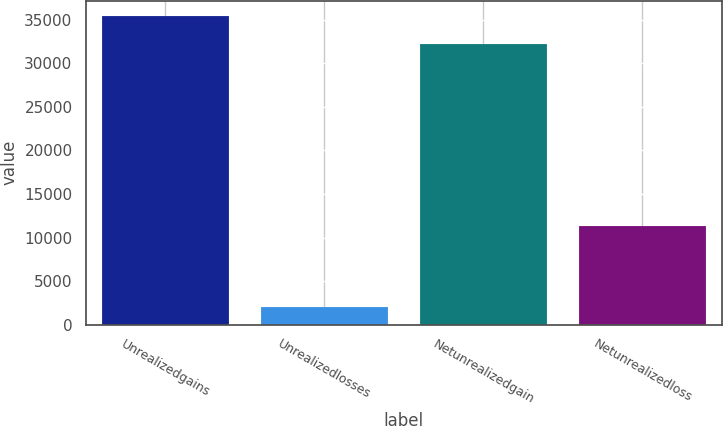<chart> <loc_0><loc_0><loc_500><loc_500><bar_chart><fcel>Unrealizedgains<fcel>Unrealizedlosses<fcel>Netunrealizedgain<fcel>Netunrealizedloss<nl><fcel>35409<fcel>2075<fcel>32190<fcel>11309<nl></chart> 